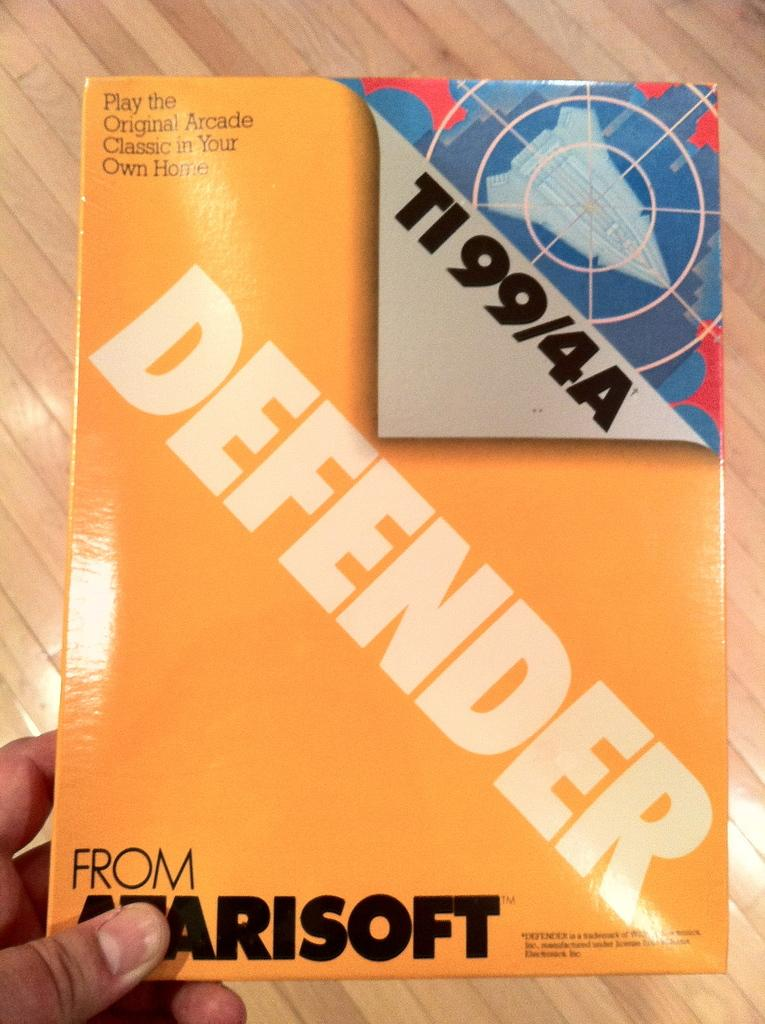<image>
Relay a brief, clear account of the picture shown. The person is holding a book with the name Defender on it. 